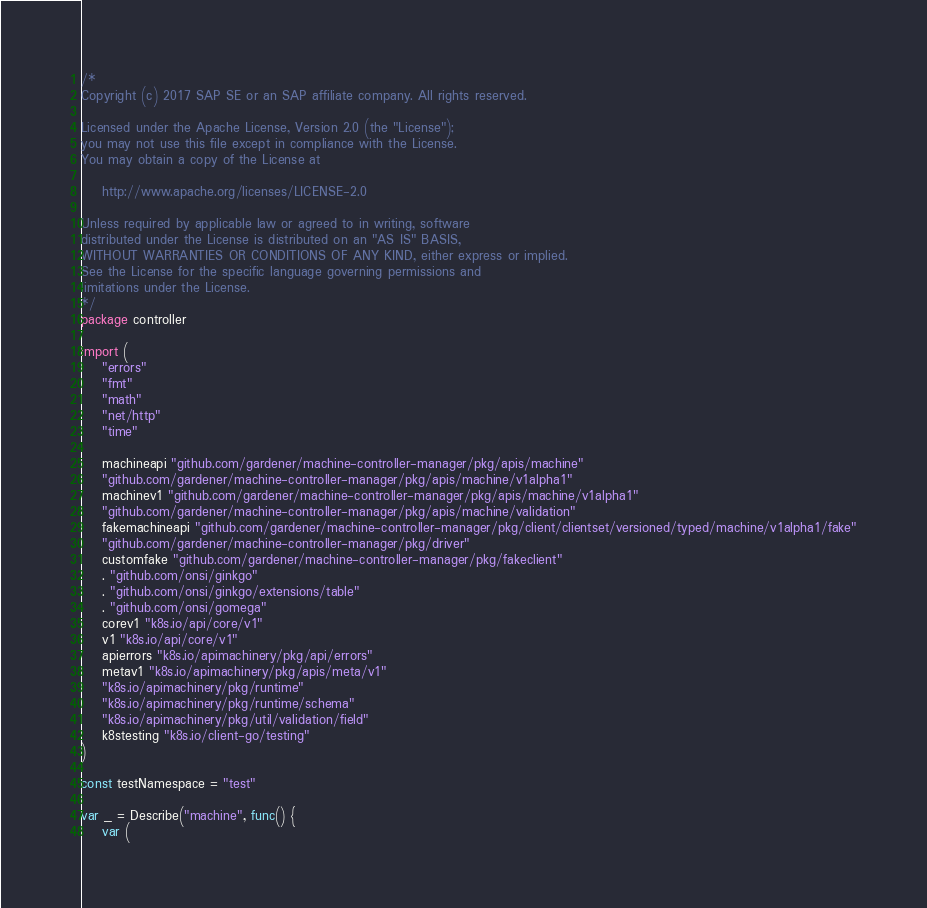Convert code to text. <code><loc_0><loc_0><loc_500><loc_500><_Go_>/*
Copyright (c) 2017 SAP SE or an SAP affiliate company. All rights reserved.

Licensed under the Apache License, Version 2.0 (the "License");
you may not use this file except in compliance with the License.
You may obtain a copy of the License at

    http://www.apache.org/licenses/LICENSE-2.0

Unless required by applicable law or agreed to in writing, software
distributed under the License is distributed on an "AS IS" BASIS,
WITHOUT WARRANTIES OR CONDITIONS OF ANY KIND, either express or implied.
See the License for the specific language governing permissions and
limitations under the License.
*/
package controller

import (
	"errors"
	"fmt"
	"math"
	"net/http"
	"time"

	machineapi "github.com/gardener/machine-controller-manager/pkg/apis/machine"
	"github.com/gardener/machine-controller-manager/pkg/apis/machine/v1alpha1"
	machinev1 "github.com/gardener/machine-controller-manager/pkg/apis/machine/v1alpha1"
	"github.com/gardener/machine-controller-manager/pkg/apis/machine/validation"
	fakemachineapi "github.com/gardener/machine-controller-manager/pkg/client/clientset/versioned/typed/machine/v1alpha1/fake"
	"github.com/gardener/machine-controller-manager/pkg/driver"
	customfake "github.com/gardener/machine-controller-manager/pkg/fakeclient"
	. "github.com/onsi/ginkgo"
	. "github.com/onsi/ginkgo/extensions/table"
	. "github.com/onsi/gomega"
	corev1 "k8s.io/api/core/v1"
	v1 "k8s.io/api/core/v1"
	apierrors "k8s.io/apimachinery/pkg/api/errors"
	metav1 "k8s.io/apimachinery/pkg/apis/meta/v1"
	"k8s.io/apimachinery/pkg/runtime"
	"k8s.io/apimachinery/pkg/runtime/schema"
	"k8s.io/apimachinery/pkg/util/validation/field"
	k8stesting "k8s.io/client-go/testing"
)

const testNamespace = "test"

var _ = Describe("machine", func() {
	var (</code> 